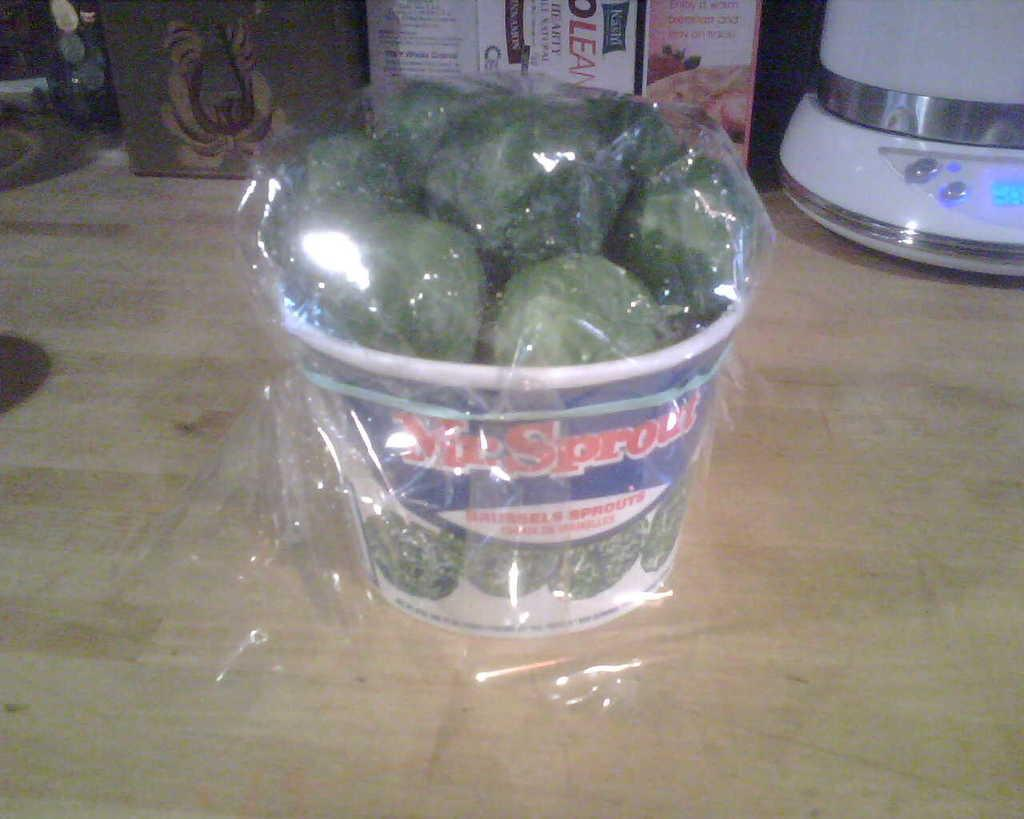<image>
Share a concise interpretation of the image provided. a bucket of broccoli with the word sprout on it 